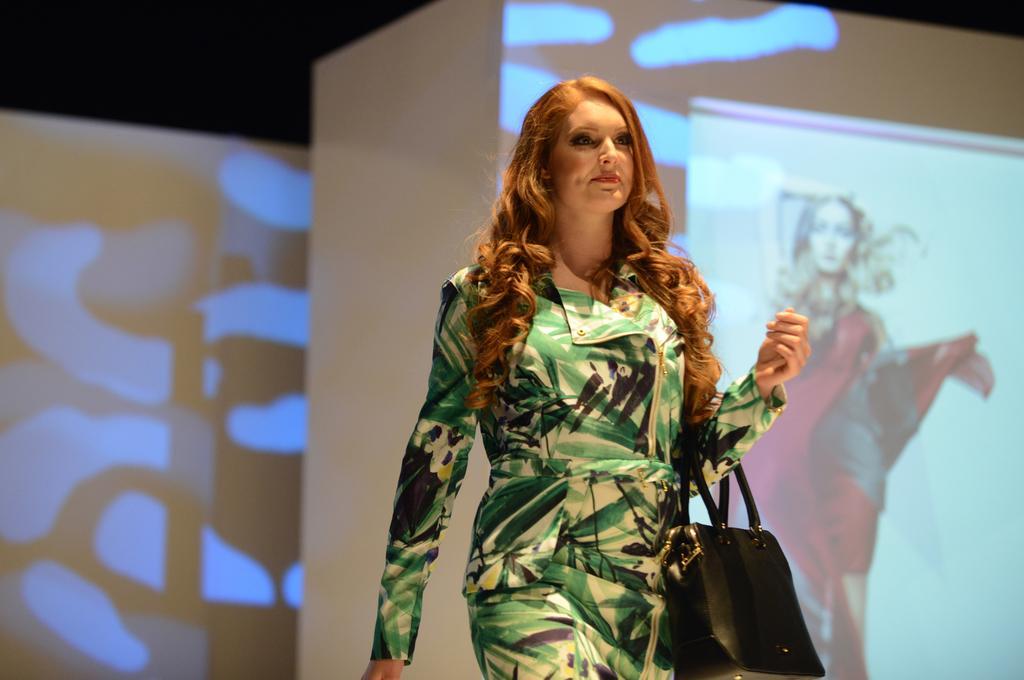In one or two sentences, can you explain what this image depicts? A woman is carrying a handbag on her hand. In the background there is a wall and screen. 